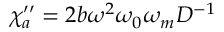<formula> <loc_0><loc_0><loc_500><loc_500>\chi _ { a } ^ { \prime \prime } = 2 b \omega ^ { 2 } \omega _ { 0 } \omega _ { m } D ^ { - 1 }</formula> 